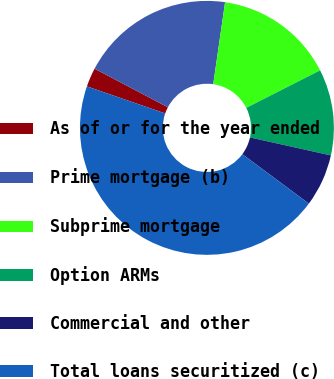Convert chart to OTSL. <chart><loc_0><loc_0><loc_500><loc_500><pie_chart><fcel>As of or for the year ended<fcel>Prime mortgage (b)<fcel>Subprime mortgage<fcel>Option ARMs<fcel>Commercial and other<fcel>Total loans securitized (c)<nl><fcel>2.42%<fcel>19.57%<fcel>15.23%<fcel>10.96%<fcel>6.69%<fcel>45.12%<nl></chart> 